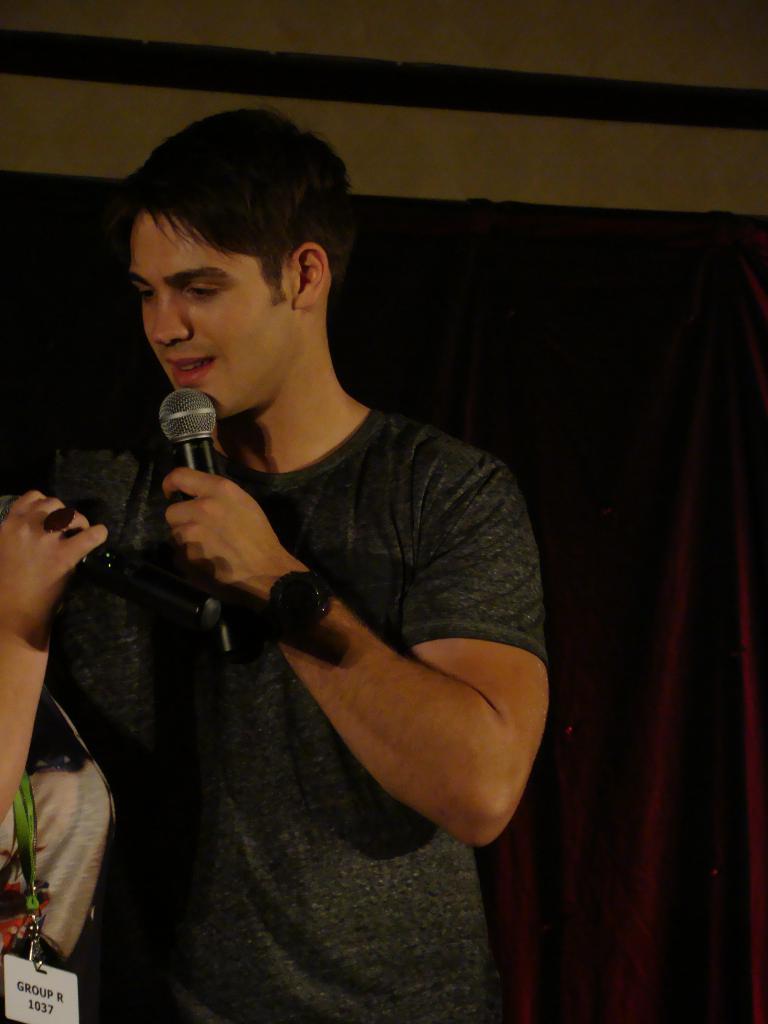Describe this image in one or two sentences. In this image I can see a person smiling and holding the mic. At the background there is a sheet attached to the wall. 